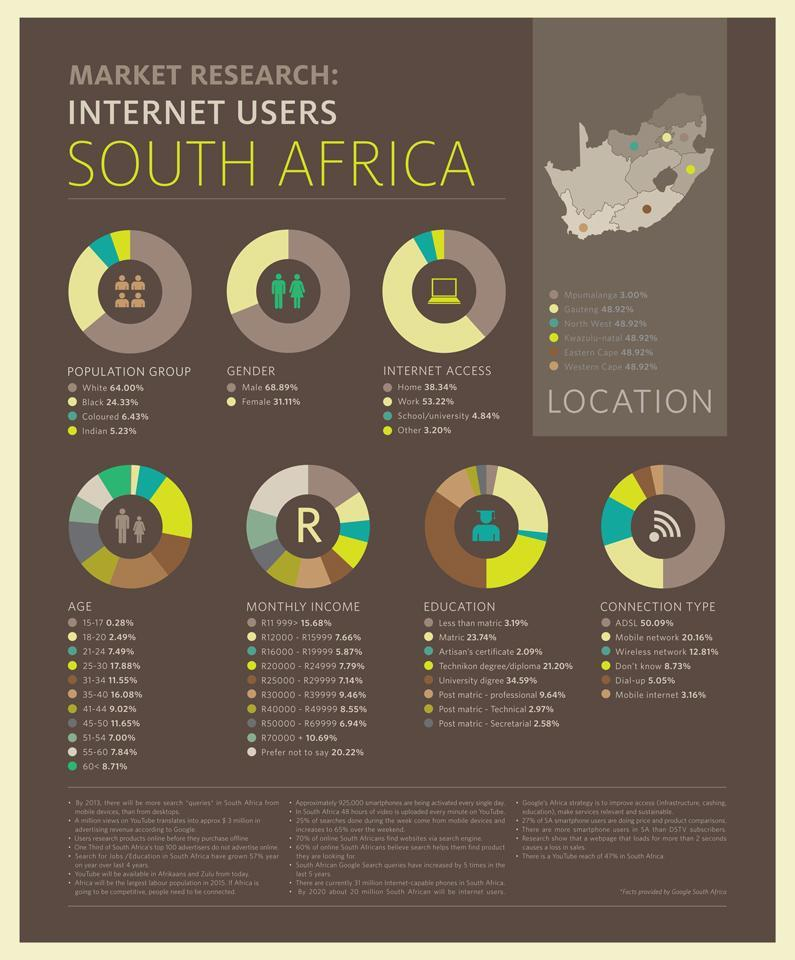What percentage of South Africans use a dial-up internet connection?
Answer the question with a short phrase. 5.05% What percentage of the internet users in South Africa are female? 31.11% Which internet connection type is used by majority of the people in South Africa? ADSL What percentage of the internet users in South Africa are male? 68.89% What percentage of South Africans aged 31-34 years use internet? 11.55% Which age group in South Africans has the highest percent of internet users? 25-30 What percentage of South Africans have access to the internet at work? 53.22% What percentage of the internet users in South Africa are blacks? 24.33% Which internet connection type is least used by the people of South Africa? Mobile internet What percentage of South Africans have access to the internet at home? 38.34% 